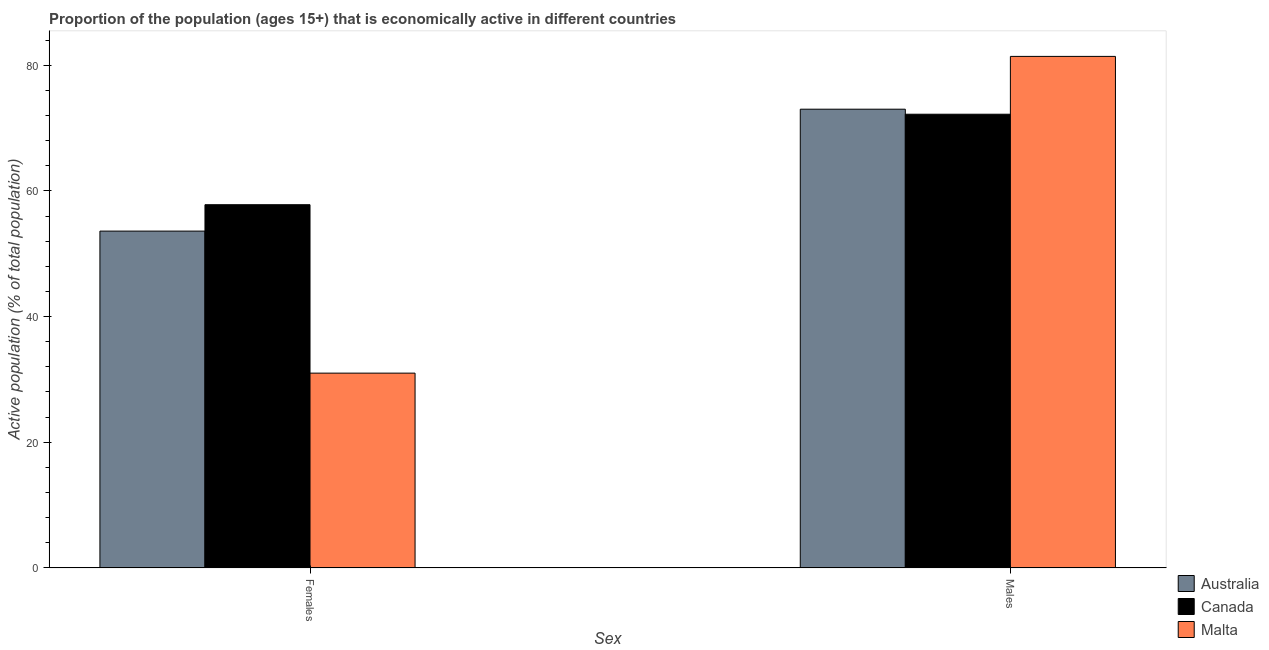How many groups of bars are there?
Your response must be concise. 2. Are the number of bars on each tick of the X-axis equal?
Offer a terse response. Yes. What is the label of the 2nd group of bars from the left?
Your answer should be compact. Males. What is the percentage of economically active female population in Canada?
Offer a very short reply. 57.8. Across all countries, what is the maximum percentage of economically active male population?
Offer a very short reply. 81.4. Across all countries, what is the minimum percentage of economically active female population?
Keep it short and to the point. 31. In which country was the percentage of economically active male population maximum?
Make the answer very short. Malta. What is the total percentage of economically active male population in the graph?
Keep it short and to the point. 226.6. What is the difference between the percentage of economically active female population in Australia and that in Canada?
Your answer should be compact. -4.2. What is the difference between the percentage of economically active female population in Malta and the percentage of economically active male population in Canada?
Provide a short and direct response. -41.2. What is the average percentage of economically active male population per country?
Give a very brief answer. 75.53. What is the difference between the percentage of economically active male population and percentage of economically active female population in Malta?
Provide a short and direct response. 50.4. In how many countries, is the percentage of economically active female population greater than 24 %?
Ensure brevity in your answer.  3. What is the ratio of the percentage of economically active male population in Canada to that in Malta?
Provide a succinct answer. 0.89. Is the percentage of economically active male population in Canada less than that in Australia?
Ensure brevity in your answer.  Yes. What does the 1st bar from the right in Females represents?
Provide a succinct answer. Malta. How many bars are there?
Give a very brief answer. 6. Are all the bars in the graph horizontal?
Give a very brief answer. No. How many countries are there in the graph?
Offer a terse response. 3. Are the values on the major ticks of Y-axis written in scientific E-notation?
Provide a short and direct response. No. Does the graph contain grids?
Provide a succinct answer. No. Where does the legend appear in the graph?
Ensure brevity in your answer.  Bottom right. How are the legend labels stacked?
Ensure brevity in your answer.  Vertical. What is the title of the graph?
Your response must be concise. Proportion of the population (ages 15+) that is economically active in different countries. What is the label or title of the X-axis?
Give a very brief answer. Sex. What is the label or title of the Y-axis?
Your answer should be compact. Active population (% of total population). What is the Active population (% of total population) in Australia in Females?
Ensure brevity in your answer.  53.6. What is the Active population (% of total population) in Canada in Females?
Ensure brevity in your answer.  57.8. What is the Active population (% of total population) of Malta in Females?
Make the answer very short. 31. What is the Active population (% of total population) of Australia in Males?
Offer a very short reply. 73. What is the Active population (% of total population) in Canada in Males?
Ensure brevity in your answer.  72.2. What is the Active population (% of total population) of Malta in Males?
Offer a terse response. 81.4. Across all Sex, what is the maximum Active population (% of total population) of Australia?
Your response must be concise. 73. Across all Sex, what is the maximum Active population (% of total population) in Canada?
Your answer should be very brief. 72.2. Across all Sex, what is the maximum Active population (% of total population) in Malta?
Keep it short and to the point. 81.4. Across all Sex, what is the minimum Active population (% of total population) of Australia?
Give a very brief answer. 53.6. Across all Sex, what is the minimum Active population (% of total population) of Canada?
Provide a short and direct response. 57.8. What is the total Active population (% of total population) in Australia in the graph?
Provide a short and direct response. 126.6. What is the total Active population (% of total population) in Canada in the graph?
Keep it short and to the point. 130. What is the total Active population (% of total population) of Malta in the graph?
Your response must be concise. 112.4. What is the difference between the Active population (% of total population) in Australia in Females and that in Males?
Your answer should be compact. -19.4. What is the difference between the Active population (% of total population) of Canada in Females and that in Males?
Keep it short and to the point. -14.4. What is the difference between the Active population (% of total population) of Malta in Females and that in Males?
Make the answer very short. -50.4. What is the difference between the Active population (% of total population) of Australia in Females and the Active population (% of total population) of Canada in Males?
Give a very brief answer. -18.6. What is the difference between the Active population (% of total population) in Australia in Females and the Active population (% of total population) in Malta in Males?
Provide a succinct answer. -27.8. What is the difference between the Active population (% of total population) in Canada in Females and the Active population (% of total population) in Malta in Males?
Provide a succinct answer. -23.6. What is the average Active population (% of total population) of Australia per Sex?
Your answer should be compact. 63.3. What is the average Active population (% of total population) of Malta per Sex?
Your answer should be very brief. 56.2. What is the difference between the Active population (% of total population) of Australia and Active population (% of total population) of Canada in Females?
Provide a short and direct response. -4.2. What is the difference between the Active population (% of total population) of Australia and Active population (% of total population) of Malta in Females?
Ensure brevity in your answer.  22.6. What is the difference between the Active population (% of total population) of Canada and Active population (% of total population) of Malta in Females?
Your response must be concise. 26.8. What is the difference between the Active population (% of total population) in Canada and Active population (% of total population) in Malta in Males?
Give a very brief answer. -9.2. What is the ratio of the Active population (% of total population) in Australia in Females to that in Males?
Offer a terse response. 0.73. What is the ratio of the Active population (% of total population) of Canada in Females to that in Males?
Your response must be concise. 0.8. What is the ratio of the Active population (% of total population) of Malta in Females to that in Males?
Offer a terse response. 0.38. What is the difference between the highest and the second highest Active population (% of total population) of Malta?
Keep it short and to the point. 50.4. What is the difference between the highest and the lowest Active population (% of total population) in Canada?
Provide a short and direct response. 14.4. What is the difference between the highest and the lowest Active population (% of total population) of Malta?
Keep it short and to the point. 50.4. 